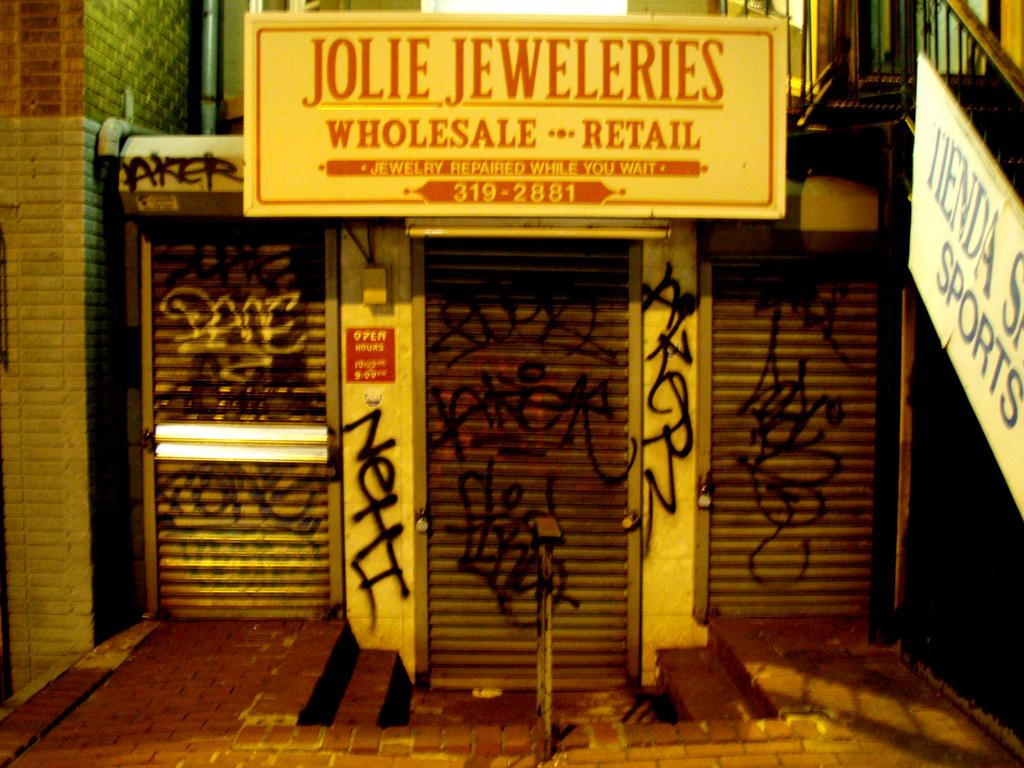<image>
Summarize the visual content of the image. the outside of a building with a sign that says 'jolie jeweleries' on it 